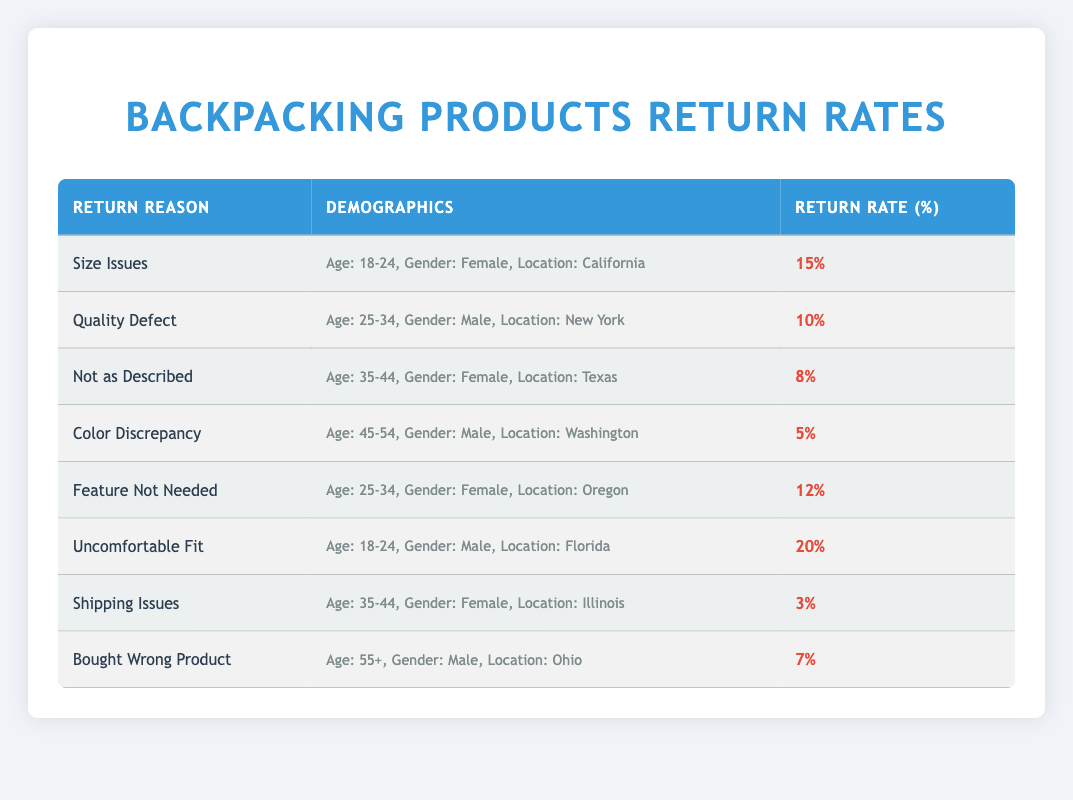What is the return rate for "Uncomfortable Fit"? According to the table, the return rate for the reason "Uncomfortable Fit" is listed as 20%.
Answer: 20% Which demographic has the highest return rate, and what is it? The demographic with the highest return rate is "Uncomfortable Fit" for age group 18-24, male, in Florida at 20%.
Answer: 20% How many return reasons have a rate of 10% or higher? The return reasons that have a rate of 10% or higher are "Size Issues" (15%), "Quality Defect" (10%), "Feature Not Needed" (12%), and "Uncomfortable Fit" (20%). That totals to 4 reasons.
Answer: 4 Is the return rate for "Shipping Issues" higher than for "Color Discrepancy"? The return rate for "Shipping Issues" is 3%, while for "Color Discrepancy" it is 5%. Since 3% is not higher than 5%, the answer is no.
Answer: No What is the average return rate for female customers across all reasons? To find the average return rate for female customers, we look at the relevant rows: "Size Issues" (15%), "Not as Described" (8%), "Shipping Issues" (3%), and "Feature Not Needed" (12%), totaling 38%. Dividing by 4 gives an average of 9.5%.
Answer: 9.5% Which age group and gender combination has the lowest return rate? The return reasons of "Color Discrepancy" (5%) and "Shipping Issues" (3%) each have male and female combinations; hence the "Shipping Issues" for age group 35-44 and female has the lowest rate at 3%.
Answer: 3% What is the difference between the highest and lowest return rates? The highest return rate is 20% for "Uncomfortable Fit", and the lowest is 3% for "Shipping Issues." Thus, the difference is calculated as 20% - 3% = 17%.
Answer: 17% Are there any return reasons with a rate of 8% or lower? Yes, there is one return reason with a rate of 8% or lower, which is "Shipping Issues" at 3% and "Color Discrepancy" at 5%.
Answer: Yes 